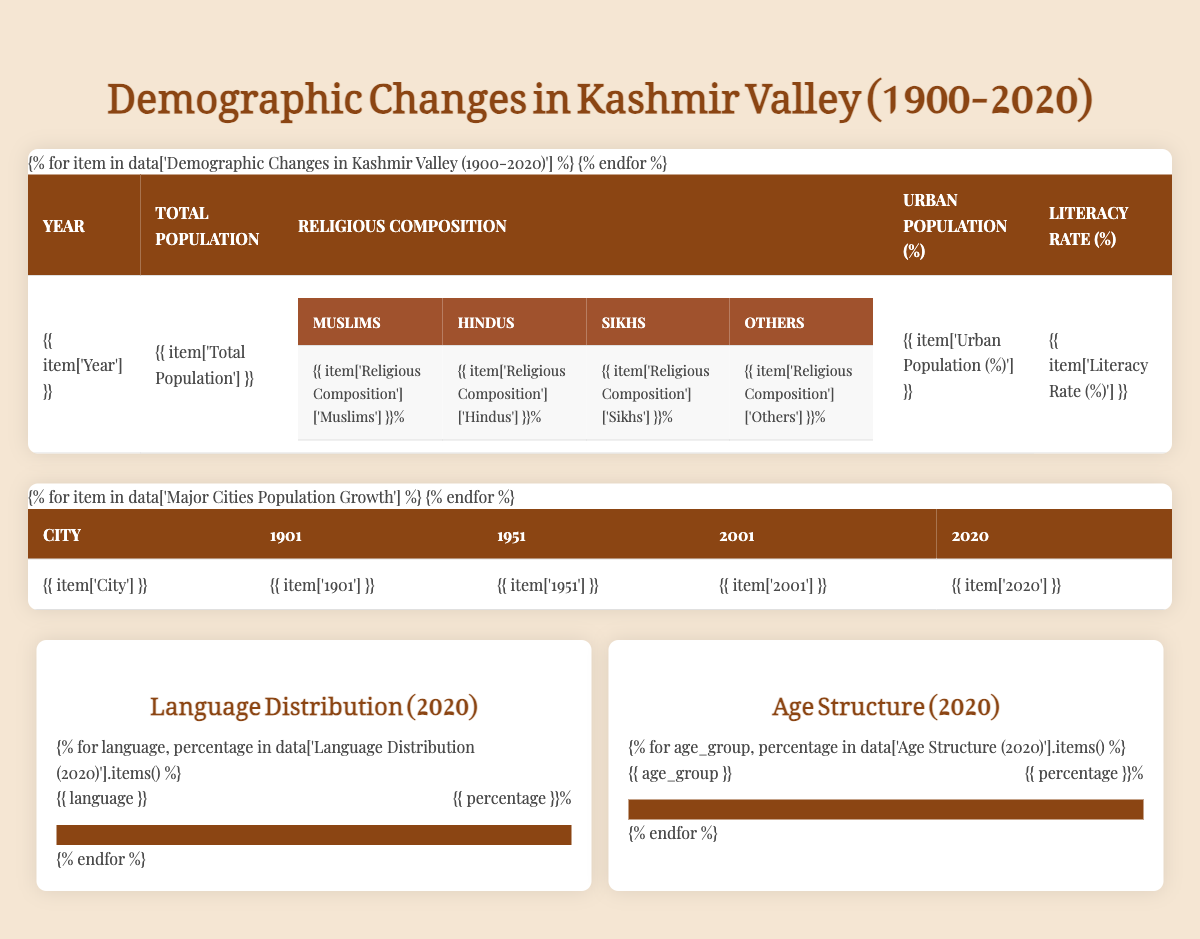What was the total population of Kashmir Valley in 1981? According to the table, the entry for the year 1981 shows that the total population was 3,134,904.
Answer: 3,134,904 What percentage of the population identified as Muslims in 2011? In the table for the year 2011, the religious composition indicates that 96.41% of the population identified as Muslims.
Answer: 96.41% What was the literacy rate in Kashmir Valley in 1941? The table indicates that the literacy rate for the year 1941 was 7.83%.
Answer: 7.83% What is the increase in total population from 1901 to 2020? The total population in 1901 was 1,157,394 and in 2020 it was 7,555,904. The increase is calculated as 7,555,904 - 1,157,394 = 6,398,510.
Answer: 6,398,510 In which year did the urban population percentage exceed 20%? By reviewing the urban population percentages from the table, it shows that this percentage first exceeds 20% in 1981 when it was 21.05%.
Answer: 1981 Is the percentage of Hindus in the population decreasing over the years? Comparing the percentage of Hindus from the years listed (from 4.01% in 1901 to 1.84% in 2020), it is evident that the percentage of Hindus decreased, confirming the statement is true.
Answer: Yes What city had a population of 898,440 in the year 2001? Looking at the data for major cities, the city of Srinagar had a population of 898,440 in the year 2001.
Answer: Srinagar What is the difference in population for Anantnag from 1901 to 2020? The population of Anantnag was 9,387 in 1901 and 209,014 in 2020. The difference is 209,014 - 9,387 = 199,627.
Answer: 199,627 What is the percentage of people aged 65 years and above in 2020? The age structure data from 2020 indicates that 6.11% of the population are aged 65 years and above.
Answer: 6.11% Which language was the most spoken in Kashmir Valley in 2020? According to the language distribution data from 2020, Kashmiri was the most spoken language with a percentage of 69.67%.
Answer: Kashmiri 